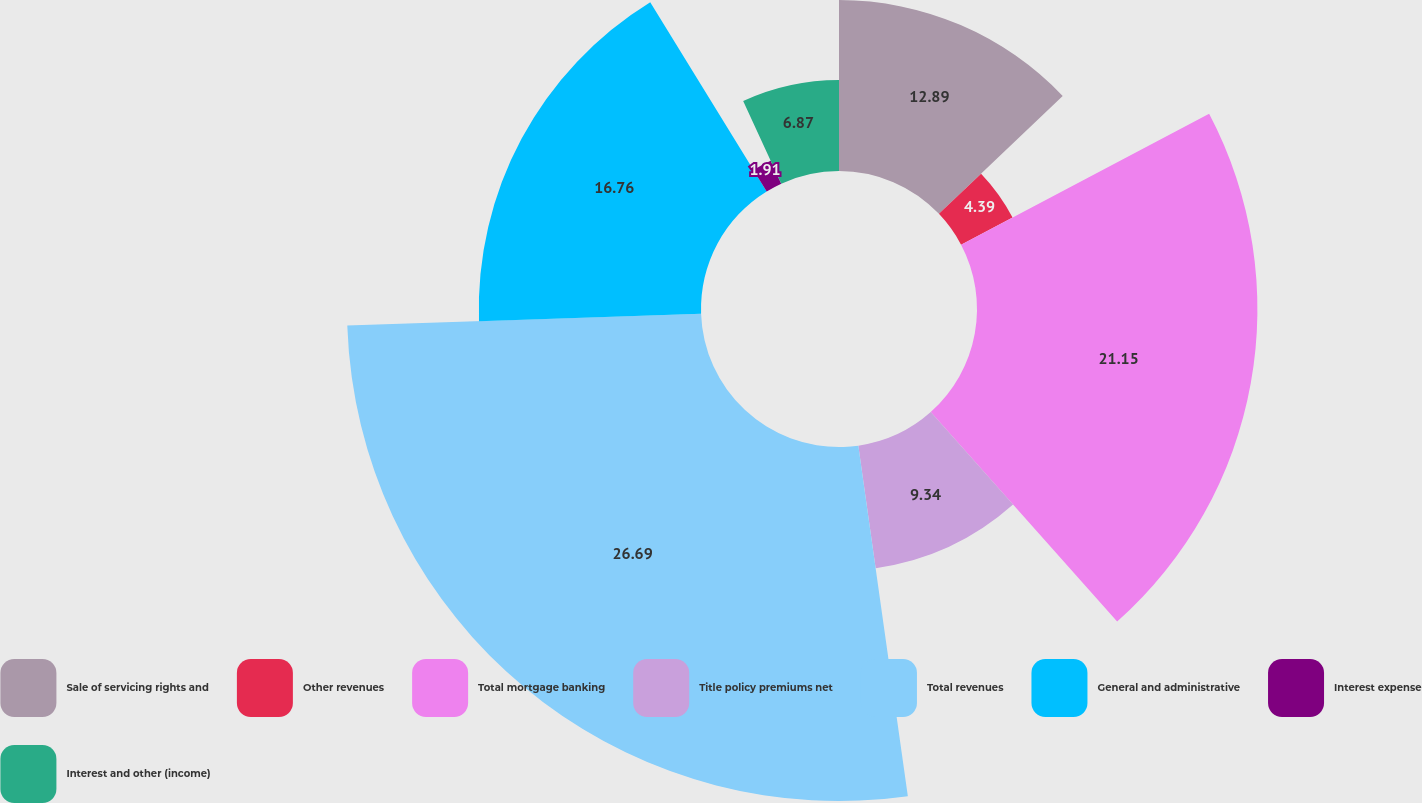Convert chart. <chart><loc_0><loc_0><loc_500><loc_500><pie_chart><fcel>Sale of servicing rights and<fcel>Other revenues<fcel>Total mortgage banking<fcel>Title policy premiums net<fcel>Total revenues<fcel>General and administrative<fcel>Interest expense<fcel>Interest and other (income)<nl><fcel>12.89%<fcel>4.39%<fcel>21.15%<fcel>9.34%<fcel>26.7%<fcel>16.76%<fcel>1.91%<fcel>6.87%<nl></chart> 